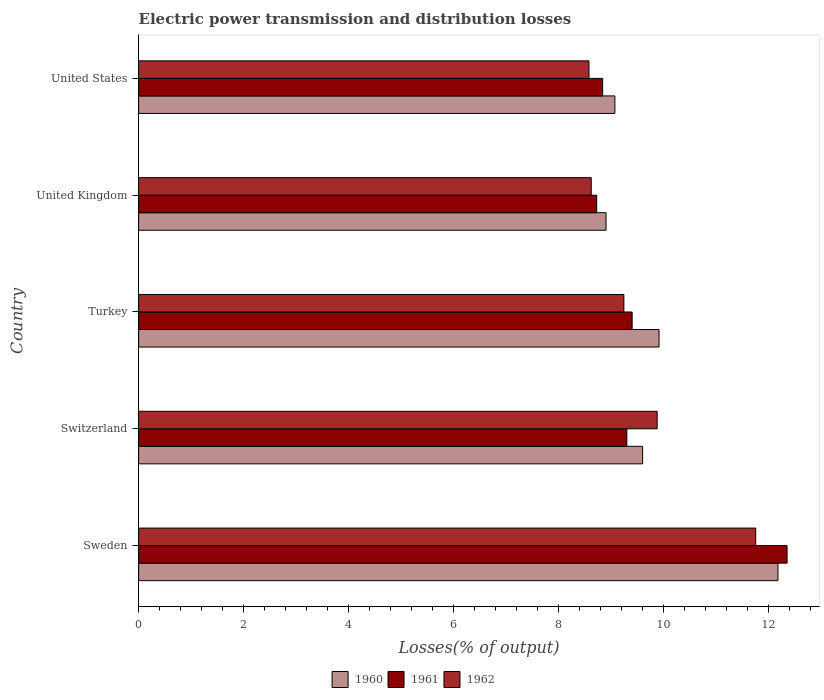How many different coloured bars are there?
Your answer should be compact. 3. Are the number of bars per tick equal to the number of legend labels?
Your answer should be very brief. Yes. Are the number of bars on each tick of the Y-axis equal?
Ensure brevity in your answer.  Yes. How many bars are there on the 2nd tick from the top?
Give a very brief answer. 3. How many bars are there on the 3rd tick from the bottom?
Offer a very short reply. 3. In how many cases, is the number of bars for a given country not equal to the number of legend labels?
Ensure brevity in your answer.  0. What is the electric power transmission and distribution losses in 1961 in United Kingdom?
Ensure brevity in your answer.  8.72. Across all countries, what is the maximum electric power transmission and distribution losses in 1962?
Your answer should be very brief. 11.75. Across all countries, what is the minimum electric power transmission and distribution losses in 1962?
Your answer should be very brief. 8.58. In which country was the electric power transmission and distribution losses in 1962 maximum?
Your answer should be compact. Sweden. In which country was the electric power transmission and distribution losses in 1962 minimum?
Offer a terse response. United States. What is the total electric power transmission and distribution losses in 1961 in the graph?
Your answer should be very brief. 48.61. What is the difference between the electric power transmission and distribution losses in 1961 in Sweden and that in United States?
Offer a terse response. 3.51. What is the difference between the electric power transmission and distribution losses in 1961 in United Kingdom and the electric power transmission and distribution losses in 1962 in Sweden?
Provide a short and direct response. -3.03. What is the average electric power transmission and distribution losses in 1960 per country?
Your response must be concise. 9.93. What is the difference between the electric power transmission and distribution losses in 1961 and electric power transmission and distribution losses in 1960 in Sweden?
Your response must be concise. 0.17. In how many countries, is the electric power transmission and distribution losses in 1962 greater than 7.6 %?
Ensure brevity in your answer.  5. What is the ratio of the electric power transmission and distribution losses in 1962 in Switzerland to that in United Kingdom?
Make the answer very short. 1.15. What is the difference between the highest and the second highest electric power transmission and distribution losses in 1962?
Keep it short and to the point. 1.88. What is the difference between the highest and the lowest electric power transmission and distribution losses in 1960?
Keep it short and to the point. 3.27. Is the sum of the electric power transmission and distribution losses in 1961 in Sweden and Turkey greater than the maximum electric power transmission and distribution losses in 1960 across all countries?
Your response must be concise. Yes. What does the 1st bar from the top in United Kingdom represents?
Keep it short and to the point. 1962. What does the 1st bar from the bottom in United Kingdom represents?
Ensure brevity in your answer.  1960. Is it the case that in every country, the sum of the electric power transmission and distribution losses in 1962 and electric power transmission and distribution losses in 1960 is greater than the electric power transmission and distribution losses in 1961?
Offer a terse response. Yes. How many bars are there?
Give a very brief answer. 15. Are the values on the major ticks of X-axis written in scientific E-notation?
Your answer should be very brief. No. Does the graph contain any zero values?
Keep it short and to the point. No. How are the legend labels stacked?
Provide a short and direct response. Horizontal. What is the title of the graph?
Keep it short and to the point. Electric power transmission and distribution losses. Does "1984" appear as one of the legend labels in the graph?
Ensure brevity in your answer.  No. What is the label or title of the X-axis?
Provide a short and direct response. Losses(% of output). What is the label or title of the Y-axis?
Your response must be concise. Country. What is the Losses(% of output) of 1960 in Sweden?
Offer a very short reply. 12.18. What is the Losses(% of output) of 1961 in Sweden?
Offer a terse response. 12.35. What is the Losses(% of output) of 1962 in Sweden?
Provide a short and direct response. 11.75. What is the Losses(% of output) of 1960 in Switzerland?
Ensure brevity in your answer.  9.6. What is the Losses(% of output) in 1961 in Switzerland?
Make the answer very short. 9.3. What is the Losses(% of output) of 1962 in Switzerland?
Your answer should be compact. 9.88. What is the Losses(% of output) of 1960 in Turkey?
Give a very brief answer. 9.91. What is the Losses(% of output) of 1961 in Turkey?
Offer a very short reply. 9.4. What is the Losses(% of output) in 1962 in Turkey?
Offer a terse response. 9.24. What is the Losses(% of output) of 1960 in United Kingdom?
Keep it short and to the point. 8.9. What is the Losses(% of output) in 1961 in United Kingdom?
Ensure brevity in your answer.  8.72. What is the Losses(% of output) in 1962 in United Kingdom?
Your answer should be compact. 8.62. What is the Losses(% of output) in 1960 in United States?
Your answer should be compact. 9.07. What is the Losses(% of output) in 1961 in United States?
Give a very brief answer. 8.84. What is the Losses(% of output) of 1962 in United States?
Ensure brevity in your answer.  8.58. Across all countries, what is the maximum Losses(% of output) of 1960?
Make the answer very short. 12.18. Across all countries, what is the maximum Losses(% of output) of 1961?
Offer a terse response. 12.35. Across all countries, what is the maximum Losses(% of output) in 1962?
Provide a succinct answer. 11.75. Across all countries, what is the minimum Losses(% of output) of 1960?
Make the answer very short. 8.9. Across all countries, what is the minimum Losses(% of output) of 1961?
Your answer should be very brief. 8.72. Across all countries, what is the minimum Losses(% of output) of 1962?
Your answer should be very brief. 8.58. What is the total Losses(% of output) in 1960 in the graph?
Your answer should be very brief. 49.66. What is the total Losses(% of output) in 1961 in the graph?
Your answer should be very brief. 48.61. What is the total Losses(% of output) of 1962 in the graph?
Give a very brief answer. 48.07. What is the difference between the Losses(% of output) of 1960 in Sweden and that in Switzerland?
Your answer should be compact. 2.58. What is the difference between the Losses(% of output) in 1961 in Sweden and that in Switzerland?
Give a very brief answer. 3.05. What is the difference between the Losses(% of output) of 1962 in Sweden and that in Switzerland?
Provide a succinct answer. 1.88. What is the difference between the Losses(% of output) of 1960 in Sweden and that in Turkey?
Make the answer very short. 2.27. What is the difference between the Losses(% of output) of 1961 in Sweden and that in Turkey?
Ensure brevity in your answer.  2.95. What is the difference between the Losses(% of output) of 1962 in Sweden and that in Turkey?
Provide a short and direct response. 2.51. What is the difference between the Losses(% of output) in 1960 in Sweden and that in United Kingdom?
Provide a succinct answer. 3.27. What is the difference between the Losses(% of output) in 1961 in Sweden and that in United Kingdom?
Give a very brief answer. 3.63. What is the difference between the Losses(% of output) in 1962 in Sweden and that in United Kingdom?
Give a very brief answer. 3.13. What is the difference between the Losses(% of output) of 1960 in Sweden and that in United States?
Your answer should be compact. 3.11. What is the difference between the Losses(% of output) in 1961 in Sweden and that in United States?
Your response must be concise. 3.51. What is the difference between the Losses(% of output) of 1962 in Sweden and that in United States?
Provide a short and direct response. 3.18. What is the difference between the Losses(% of output) of 1960 in Switzerland and that in Turkey?
Keep it short and to the point. -0.31. What is the difference between the Losses(% of output) in 1961 in Switzerland and that in Turkey?
Keep it short and to the point. -0.1. What is the difference between the Losses(% of output) of 1962 in Switzerland and that in Turkey?
Provide a short and direct response. 0.63. What is the difference between the Losses(% of output) of 1960 in Switzerland and that in United Kingdom?
Offer a very short reply. 0.7. What is the difference between the Losses(% of output) in 1961 in Switzerland and that in United Kingdom?
Offer a terse response. 0.57. What is the difference between the Losses(% of output) of 1962 in Switzerland and that in United Kingdom?
Keep it short and to the point. 1.26. What is the difference between the Losses(% of output) of 1960 in Switzerland and that in United States?
Offer a very short reply. 0.53. What is the difference between the Losses(% of output) of 1961 in Switzerland and that in United States?
Your answer should be compact. 0.46. What is the difference between the Losses(% of output) of 1962 in Switzerland and that in United States?
Provide a succinct answer. 1.3. What is the difference between the Losses(% of output) of 1960 in Turkey and that in United Kingdom?
Keep it short and to the point. 1.01. What is the difference between the Losses(% of output) in 1961 in Turkey and that in United Kingdom?
Provide a short and direct response. 0.68. What is the difference between the Losses(% of output) of 1962 in Turkey and that in United Kingdom?
Make the answer very short. 0.62. What is the difference between the Losses(% of output) in 1960 in Turkey and that in United States?
Provide a short and direct response. 0.84. What is the difference between the Losses(% of output) of 1961 in Turkey and that in United States?
Ensure brevity in your answer.  0.56. What is the difference between the Losses(% of output) of 1962 in Turkey and that in United States?
Provide a succinct answer. 0.66. What is the difference between the Losses(% of output) in 1960 in United Kingdom and that in United States?
Offer a terse response. -0.17. What is the difference between the Losses(% of output) in 1961 in United Kingdom and that in United States?
Provide a succinct answer. -0.11. What is the difference between the Losses(% of output) of 1962 in United Kingdom and that in United States?
Your response must be concise. 0.04. What is the difference between the Losses(% of output) of 1960 in Sweden and the Losses(% of output) of 1961 in Switzerland?
Make the answer very short. 2.88. What is the difference between the Losses(% of output) of 1960 in Sweden and the Losses(% of output) of 1962 in Switzerland?
Ensure brevity in your answer.  2.3. What is the difference between the Losses(% of output) in 1961 in Sweden and the Losses(% of output) in 1962 in Switzerland?
Provide a short and direct response. 2.47. What is the difference between the Losses(% of output) of 1960 in Sweden and the Losses(% of output) of 1961 in Turkey?
Your answer should be very brief. 2.78. What is the difference between the Losses(% of output) in 1960 in Sweden and the Losses(% of output) in 1962 in Turkey?
Your answer should be very brief. 2.94. What is the difference between the Losses(% of output) of 1961 in Sweden and the Losses(% of output) of 1962 in Turkey?
Give a very brief answer. 3.11. What is the difference between the Losses(% of output) of 1960 in Sweden and the Losses(% of output) of 1961 in United Kingdom?
Your response must be concise. 3.45. What is the difference between the Losses(% of output) in 1960 in Sweden and the Losses(% of output) in 1962 in United Kingdom?
Keep it short and to the point. 3.56. What is the difference between the Losses(% of output) of 1961 in Sweden and the Losses(% of output) of 1962 in United Kingdom?
Offer a very short reply. 3.73. What is the difference between the Losses(% of output) of 1960 in Sweden and the Losses(% of output) of 1961 in United States?
Ensure brevity in your answer.  3.34. What is the difference between the Losses(% of output) of 1960 in Sweden and the Losses(% of output) of 1962 in United States?
Your answer should be very brief. 3.6. What is the difference between the Losses(% of output) in 1961 in Sweden and the Losses(% of output) in 1962 in United States?
Your response must be concise. 3.77. What is the difference between the Losses(% of output) of 1960 in Switzerland and the Losses(% of output) of 1961 in Turkey?
Keep it short and to the point. 0.2. What is the difference between the Losses(% of output) of 1960 in Switzerland and the Losses(% of output) of 1962 in Turkey?
Offer a terse response. 0.36. What is the difference between the Losses(% of output) of 1961 in Switzerland and the Losses(% of output) of 1962 in Turkey?
Offer a terse response. 0.06. What is the difference between the Losses(% of output) in 1960 in Switzerland and the Losses(% of output) in 1961 in United Kingdom?
Offer a terse response. 0.88. What is the difference between the Losses(% of output) of 1960 in Switzerland and the Losses(% of output) of 1962 in United Kingdom?
Make the answer very short. 0.98. What is the difference between the Losses(% of output) of 1961 in Switzerland and the Losses(% of output) of 1962 in United Kingdom?
Your answer should be compact. 0.68. What is the difference between the Losses(% of output) of 1960 in Switzerland and the Losses(% of output) of 1961 in United States?
Offer a very short reply. 0.76. What is the difference between the Losses(% of output) in 1960 in Switzerland and the Losses(% of output) in 1962 in United States?
Provide a succinct answer. 1.02. What is the difference between the Losses(% of output) in 1961 in Switzerland and the Losses(% of output) in 1962 in United States?
Offer a terse response. 0.72. What is the difference between the Losses(% of output) in 1960 in Turkey and the Losses(% of output) in 1961 in United Kingdom?
Your answer should be compact. 1.19. What is the difference between the Losses(% of output) of 1960 in Turkey and the Losses(% of output) of 1962 in United Kingdom?
Offer a very short reply. 1.29. What is the difference between the Losses(% of output) in 1961 in Turkey and the Losses(% of output) in 1962 in United Kingdom?
Offer a terse response. 0.78. What is the difference between the Losses(% of output) in 1960 in Turkey and the Losses(% of output) in 1961 in United States?
Provide a short and direct response. 1.07. What is the difference between the Losses(% of output) in 1960 in Turkey and the Losses(% of output) in 1962 in United States?
Your answer should be compact. 1.33. What is the difference between the Losses(% of output) in 1961 in Turkey and the Losses(% of output) in 1962 in United States?
Offer a terse response. 0.82. What is the difference between the Losses(% of output) in 1960 in United Kingdom and the Losses(% of output) in 1961 in United States?
Ensure brevity in your answer.  0.06. What is the difference between the Losses(% of output) in 1960 in United Kingdom and the Losses(% of output) in 1962 in United States?
Your answer should be very brief. 0.33. What is the difference between the Losses(% of output) of 1961 in United Kingdom and the Losses(% of output) of 1962 in United States?
Keep it short and to the point. 0.15. What is the average Losses(% of output) in 1960 per country?
Keep it short and to the point. 9.93. What is the average Losses(% of output) in 1961 per country?
Your answer should be very brief. 9.72. What is the average Losses(% of output) in 1962 per country?
Offer a very short reply. 9.61. What is the difference between the Losses(% of output) of 1960 and Losses(% of output) of 1961 in Sweden?
Ensure brevity in your answer.  -0.17. What is the difference between the Losses(% of output) in 1960 and Losses(% of output) in 1962 in Sweden?
Offer a very short reply. 0.42. What is the difference between the Losses(% of output) in 1961 and Losses(% of output) in 1962 in Sweden?
Give a very brief answer. 0.6. What is the difference between the Losses(% of output) in 1960 and Losses(% of output) in 1961 in Switzerland?
Your response must be concise. 0.3. What is the difference between the Losses(% of output) in 1960 and Losses(% of output) in 1962 in Switzerland?
Offer a very short reply. -0.28. What is the difference between the Losses(% of output) of 1961 and Losses(% of output) of 1962 in Switzerland?
Ensure brevity in your answer.  -0.58. What is the difference between the Losses(% of output) of 1960 and Losses(% of output) of 1961 in Turkey?
Make the answer very short. 0.51. What is the difference between the Losses(% of output) of 1960 and Losses(% of output) of 1962 in Turkey?
Provide a succinct answer. 0.67. What is the difference between the Losses(% of output) of 1961 and Losses(% of output) of 1962 in Turkey?
Your answer should be very brief. 0.16. What is the difference between the Losses(% of output) in 1960 and Losses(% of output) in 1961 in United Kingdom?
Offer a very short reply. 0.18. What is the difference between the Losses(% of output) of 1960 and Losses(% of output) of 1962 in United Kingdom?
Your answer should be compact. 0.28. What is the difference between the Losses(% of output) in 1961 and Losses(% of output) in 1962 in United Kingdom?
Keep it short and to the point. 0.1. What is the difference between the Losses(% of output) in 1960 and Losses(% of output) in 1961 in United States?
Offer a very short reply. 0.23. What is the difference between the Losses(% of output) in 1960 and Losses(% of output) in 1962 in United States?
Provide a succinct answer. 0.49. What is the difference between the Losses(% of output) of 1961 and Losses(% of output) of 1962 in United States?
Your answer should be compact. 0.26. What is the ratio of the Losses(% of output) of 1960 in Sweden to that in Switzerland?
Make the answer very short. 1.27. What is the ratio of the Losses(% of output) in 1961 in Sweden to that in Switzerland?
Keep it short and to the point. 1.33. What is the ratio of the Losses(% of output) of 1962 in Sweden to that in Switzerland?
Provide a succinct answer. 1.19. What is the ratio of the Losses(% of output) of 1960 in Sweden to that in Turkey?
Offer a terse response. 1.23. What is the ratio of the Losses(% of output) of 1961 in Sweden to that in Turkey?
Your response must be concise. 1.31. What is the ratio of the Losses(% of output) in 1962 in Sweden to that in Turkey?
Ensure brevity in your answer.  1.27. What is the ratio of the Losses(% of output) of 1960 in Sweden to that in United Kingdom?
Offer a very short reply. 1.37. What is the ratio of the Losses(% of output) in 1961 in Sweden to that in United Kingdom?
Provide a short and direct response. 1.42. What is the ratio of the Losses(% of output) of 1962 in Sweden to that in United Kingdom?
Give a very brief answer. 1.36. What is the ratio of the Losses(% of output) of 1960 in Sweden to that in United States?
Your answer should be very brief. 1.34. What is the ratio of the Losses(% of output) in 1961 in Sweden to that in United States?
Offer a terse response. 1.4. What is the ratio of the Losses(% of output) in 1962 in Sweden to that in United States?
Provide a short and direct response. 1.37. What is the ratio of the Losses(% of output) of 1960 in Switzerland to that in Turkey?
Your answer should be compact. 0.97. What is the ratio of the Losses(% of output) in 1961 in Switzerland to that in Turkey?
Make the answer very short. 0.99. What is the ratio of the Losses(% of output) of 1962 in Switzerland to that in Turkey?
Provide a short and direct response. 1.07. What is the ratio of the Losses(% of output) in 1960 in Switzerland to that in United Kingdom?
Provide a short and direct response. 1.08. What is the ratio of the Losses(% of output) of 1961 in Switzerland to that in United Kingdom?
Provide a succinct answer. 1.07. What is the ratio of the Losses(% of output) in 1962 in Switzerland to that in United Kingdom?
Provide a short and direct response. 1.15. What is the ratio of the Losses(% of output) of 1960 in Switzerland to that in United States?
Ensure brevity in your answer.  1.06. What is the ratio of the Losses(% of output) of 1961 in Switzerland to that in United States?
Keep it short and to the point. 1.05. What is the ratio of the Losses(% of output) of 1962 in Switzerland to that in United States?
Keep it short and to the point. 1.15. What is the ratio of the Losses(% of output) in 1960 in Turkey to that in United Kingdom?
Make the answer very short. 1.11. What is the ratio of the Losses(% of output) in 1961 in Turkey to that in United Kingdom?
Offer a terse response. 1.08. What is the ratio of the Losses(% of output) in 1962 in Turkey to that in United Kingdom?
Keep it short and to the point. 1.07. What is the ratio of the Losses(% of output) in 1960 in Turkey to that in United States?
Offer a very short reply. 1.09. What is the ratio of the Losses(% of output) of 1961 in Turkey to that in United States?
Your answer should be compact. 1.06. What is the ratio of the Losses(% of output) in 1962 in Turkey to that in United States?
Give a very brief answer. 1.08. What is the ratio of the Losses(% of output) of 1960 in United Kingdom to that in United States?
Provide a short and direct response. 0.98. What is the ratio of the Losses(% of output) in 1961 in United Kingdom to that in United States?
Your response must be concise. 0.99. What is the ratio of the Losses(% of output) of 1962 in United Kingdom to that in United States?
Ensure brevity in your answer.  1.01. What is the difference between the highest and the second highest Losses(% of output) of 1960?
Provide a short and direct response. 2.27. What is the difference between the highest and the second highest Losses(% of output) of 1961?
Your answer should be compact. 2.95. What is the difference between the highest and the second highest Losses(% of output) of 1962?
Your response must be concise. 1.88. What is the difference between the highest and the lowest Losses(% of output) of 1960?
Keep it short and to the point. 3.27. What is the difference between the highest and the lowest Losses(% of output) in 1961?
Make the answer very short. 3.63. What is the difference between the highest and the lowest Losses(% of output) in 1962?
Your answer should be very brief. 3.18. 